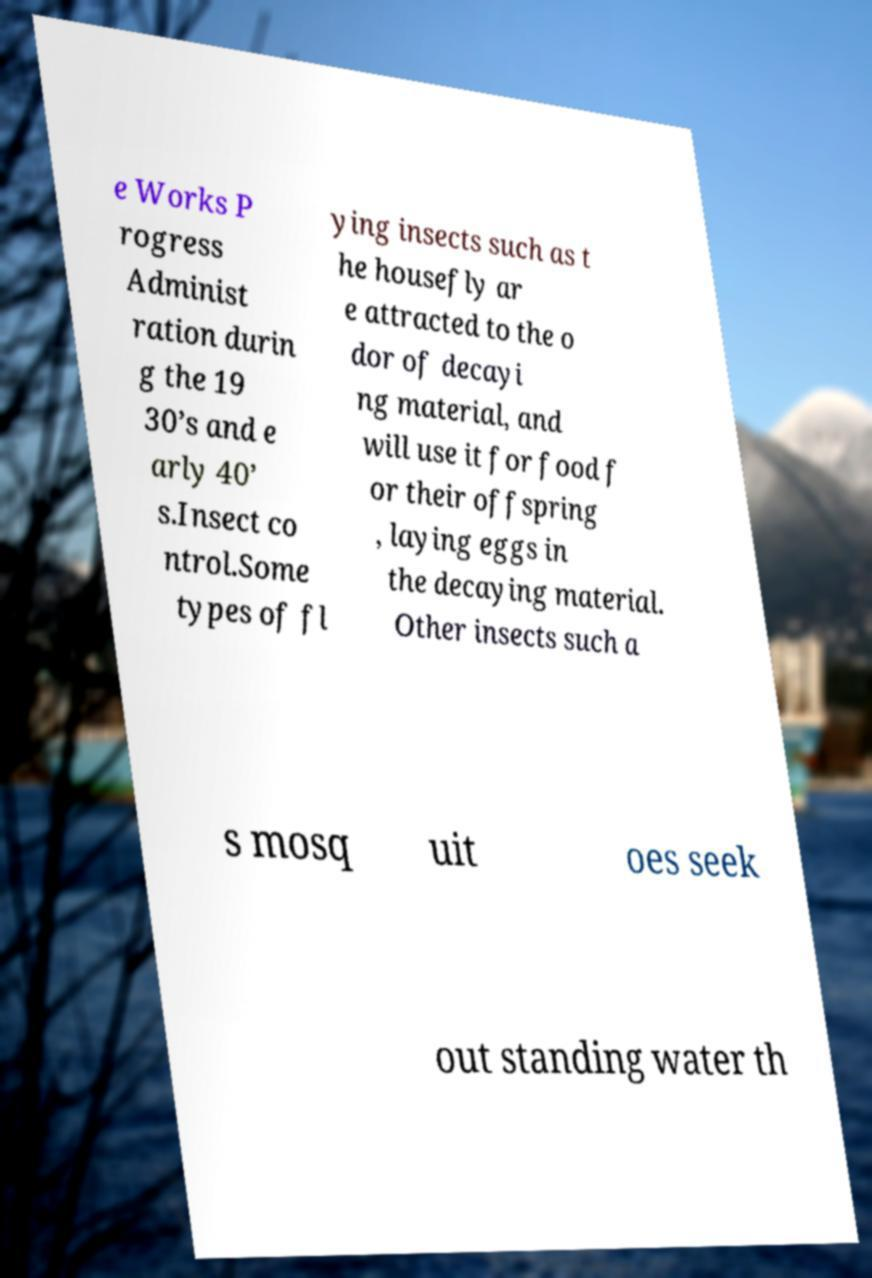Can you accurately transcribe the text from the provided image for me? e Works P rogress Administ ration durin g the 19 30’s and e arly 40’ s.Insect co ntrol.Some types of fl ying insects such as t he housefly ar e attracted to the o dor of decayi ng material, and will use it for food f or their offspring , laying eggs in the decaying material. Other insects such a s mosq uit oes seek out standing water th 